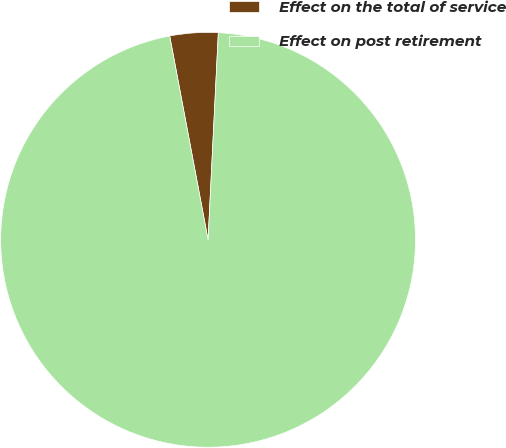<chart> <loc_0><loc_0><loc_500><loc_500><pie_chart><fcel>Effect on the total of service<fcel>Effect on post retirement<nl><fcel>3.75%<fcel>96.25%<nl></chart> 